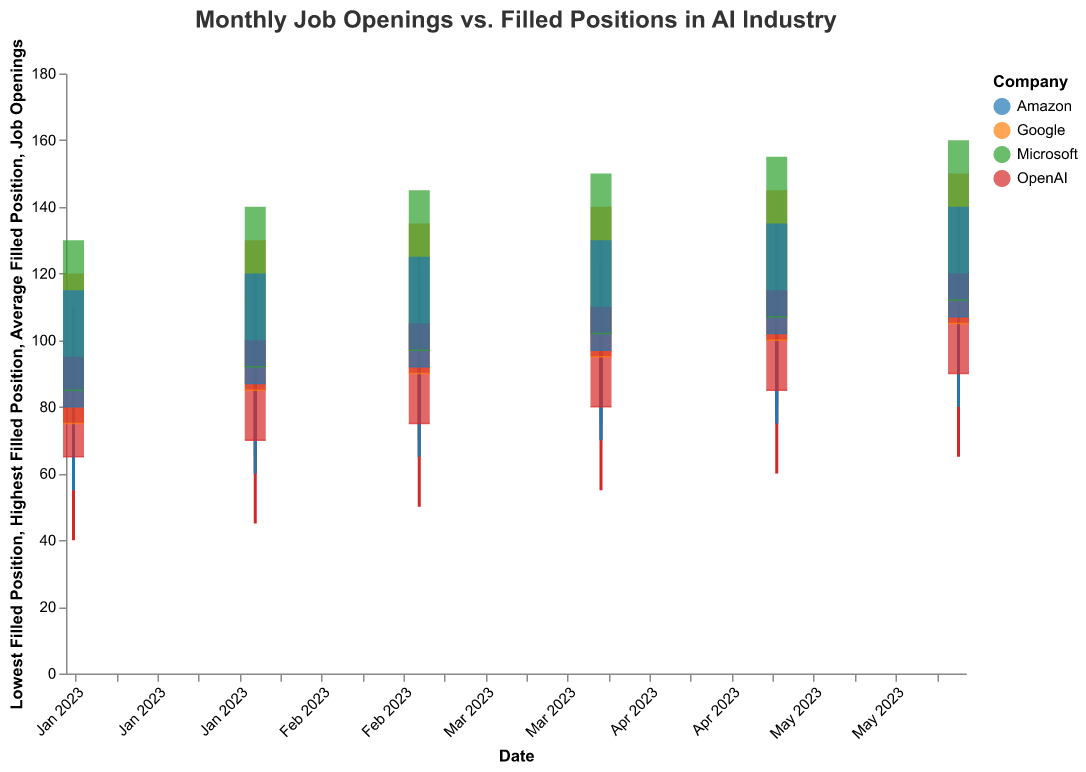What is the title of the plot? The title is usually located at the top of a plot or graph and immediately describes what the visualization is about. In this plot, the title is written at the top.
Answer: "Monthly Job Openings vs. Filled Positions in AI Industry" Which company had the highest average filled position in June 2023? To find this, you need to look at the data points for each company in June 2023. Identify the bar and tick with the highest average filled position value.
Answer: Microsoft What is the range of filled positions for Google in February 2023? Look at the candlestick-like structure for Google in February 2023. Note the lowest and highest filled positions and compute the range.
Answer: 60 to 110 What is the trend in job openings for Amazon from January to June 2023? Observe the heights of the bars for Amazon from January to June 2023 to identify the trend. Note the direction of change over the months.
Answer: Increasing Which company had the largest increase in job openings from January to June 2023? By comparing the heights of the bars representing job openings for each company in January and June 2023, identify the company with the highest difference. Microsoft increased from 130 to 160, which is the largest.
Answer: Microsoft Which company had the smallest fluctuation in filled positions in April 2023? Examine the candlestick structure for each company in April 2023. The smallest fluctuation will have the shortest rule (smallest difference between highest and lowest filled positions).
Answer: OpenAI What was the average filled position for Microsoft in April 2023, and how does it compare to Amazon's in the same month? Look at the tick mark representing the average filled position for both Microsoft and Amazon in April 2023. Note down both values and compare.
Answer: Microsoft: 102, Amazon: 97. Microsoft is higher In which month did Google's average filled position reach its highest point? Observe the tick marks for Google across all months and identify the month with the highest average filled position (highest tick mark).
Answer: June 2023 Compare job openings between Microsoft and OpenAI in May 2023. Which company posted more job openings? Look at the height of the bars for Microsoft and OpenAI in May 2023. Identify which bar is higher.
Answer: Microsoft What is the difference in the highest filled positions between Amazon and Google in March 2023? Identify the highest filled positions for both companies in March 2023 from the top end of their candlestick structures. Calculate the difference.
Answer: 120 - 115 = 5 